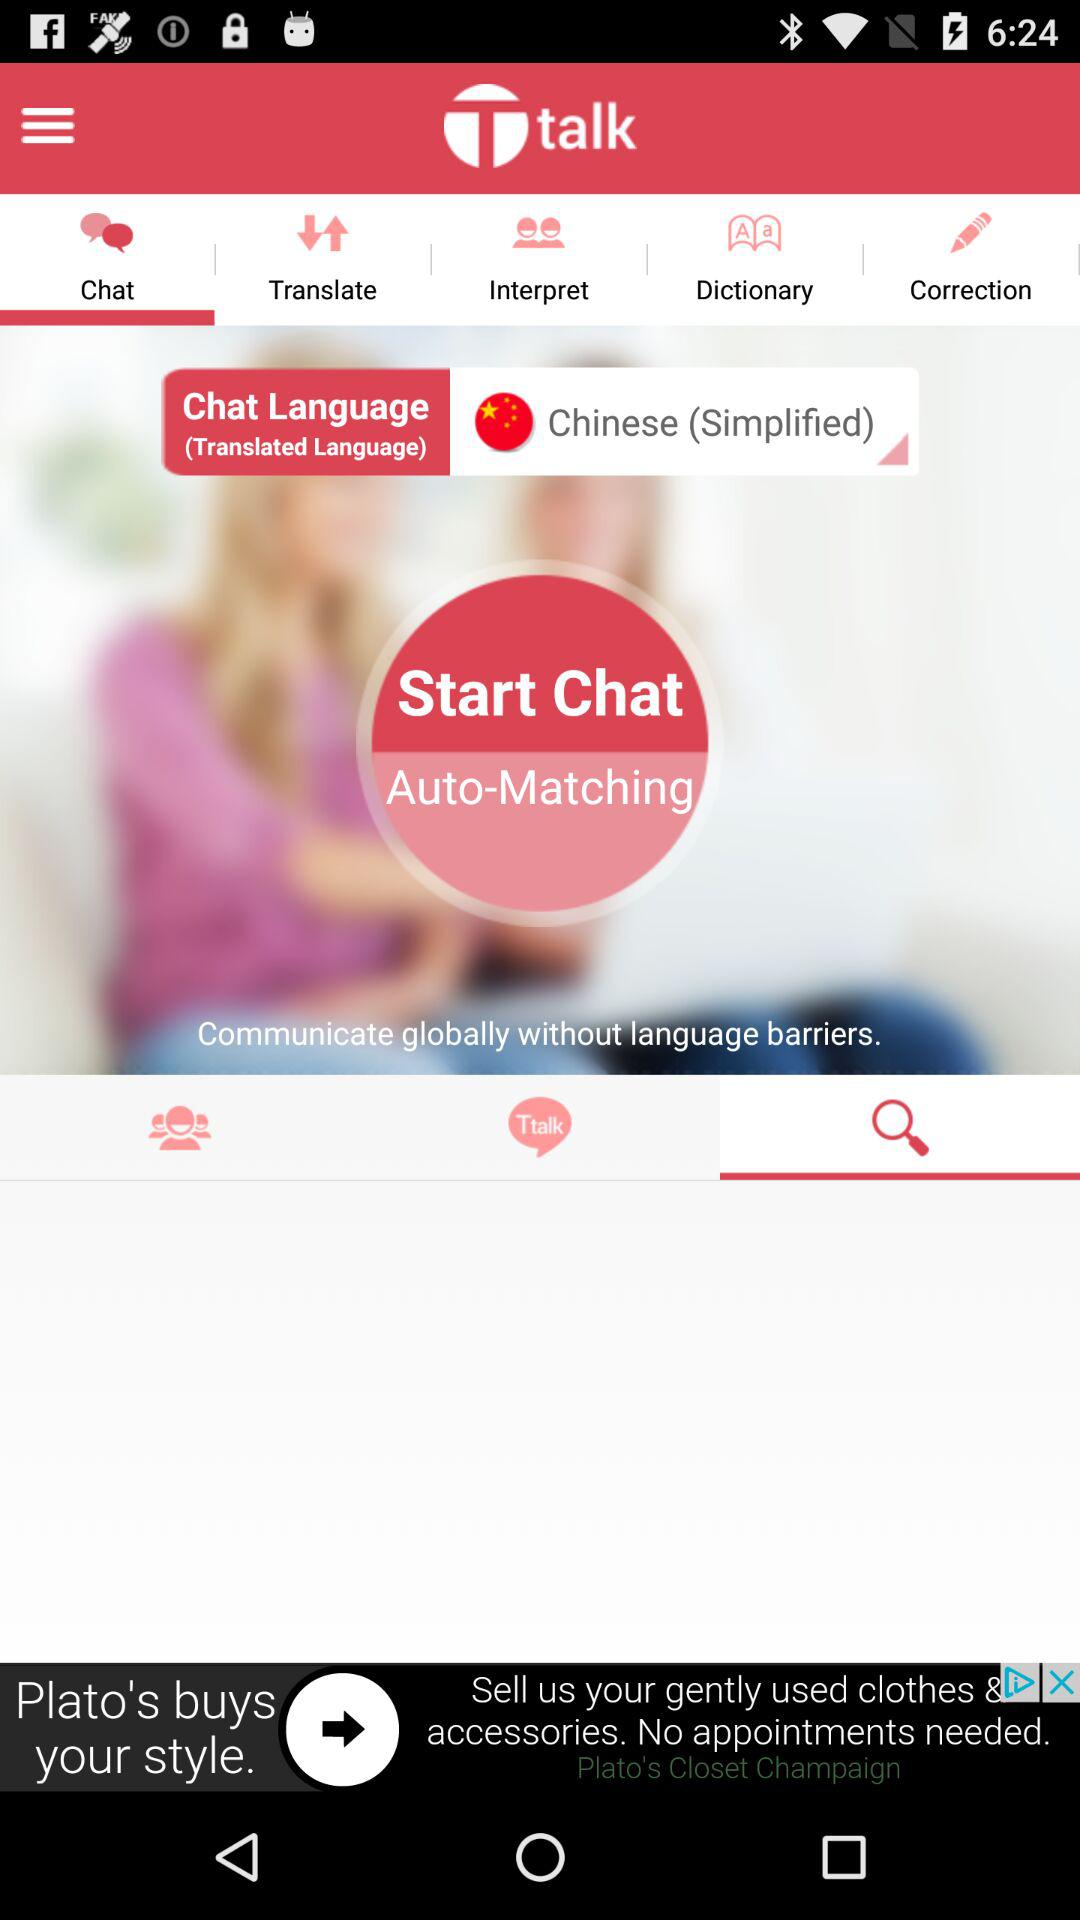What is the name of the application? The name of the application is "Ttalk". 